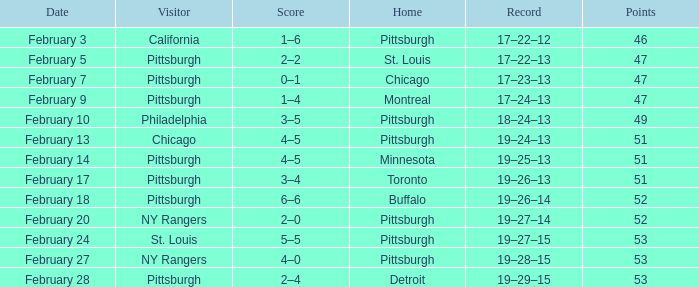What is the score for a visitor of new york rangers, having a 19-28-15 record? 4–0. 